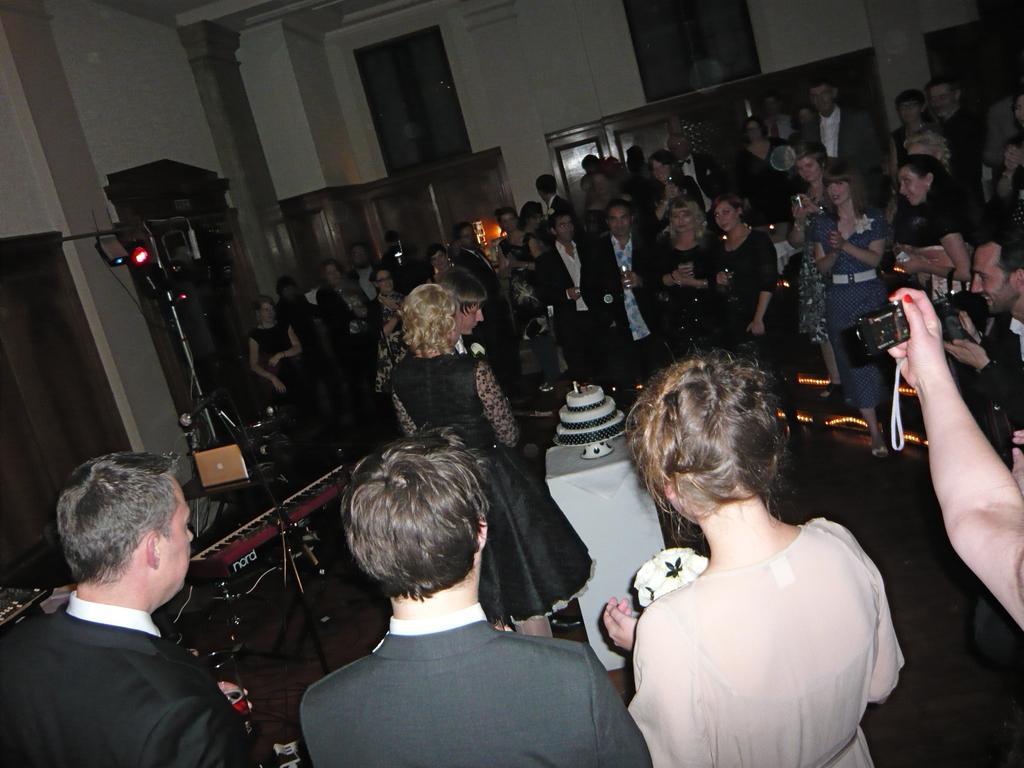In one or two sentences, can you explain what this image depicts? A couple are celebrating their engagement with people gathered around them. 